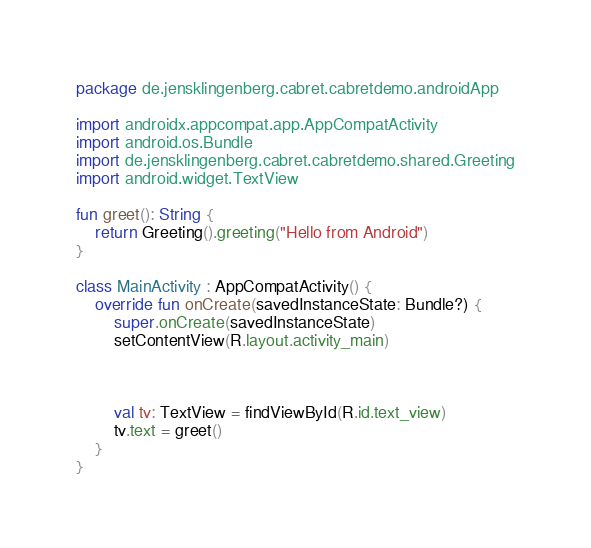Convert code to text. <code><loc_0><loc_0><loc_500><loc_500><_Kotlin_>package de.jensklingenberg.cabret.cabretdemo.androidApp

import androidx.appcompat.app.AppCompatActivity
import android.os.Bundle
import de.jensklingenberg.cabret.cabretdemo.shared.Greeting
import android.widget.TextView

fun greet(): String {
    return Greeting().greeting("Hello from Android")
}

class MainActivity : AppCompatActivity() {
    override fun onCreate(savedInstanceState: Bundle?) {
        super.onCreate(savedInstanceState)
        setContentView(R.layout.activity_main)



        val tv: TextView = findViewById(R.id.text_view)
        tv.text = greet()
    }
}
</code> 